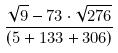Convert formula to latex. <formula><loc_0><loc_0><loc_500><loc_500>\frac { \sqrt { 9 } - 7 3 \cdot \sqrt { 2 7 6 } } { ( 5 + 1 3 3 + 3 0 6 ) }</formula> 